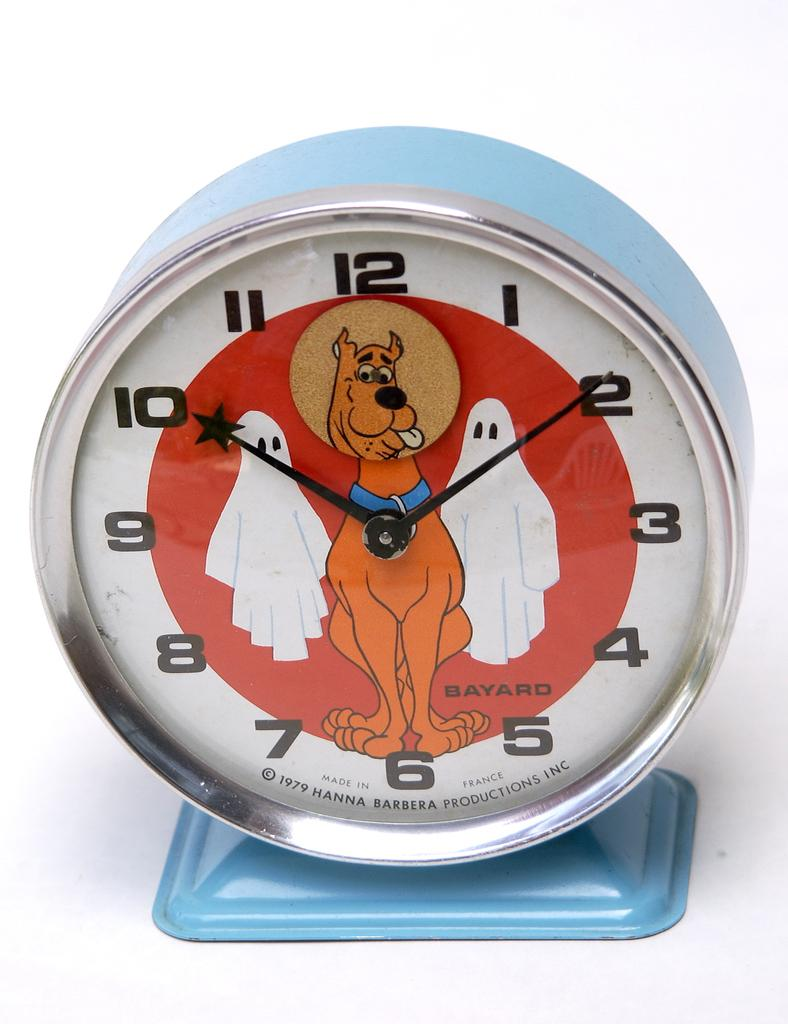<image>
Give a short and clear explanation of the subsequent image. An alarm clock with Scooby Doo that reads 10:10 